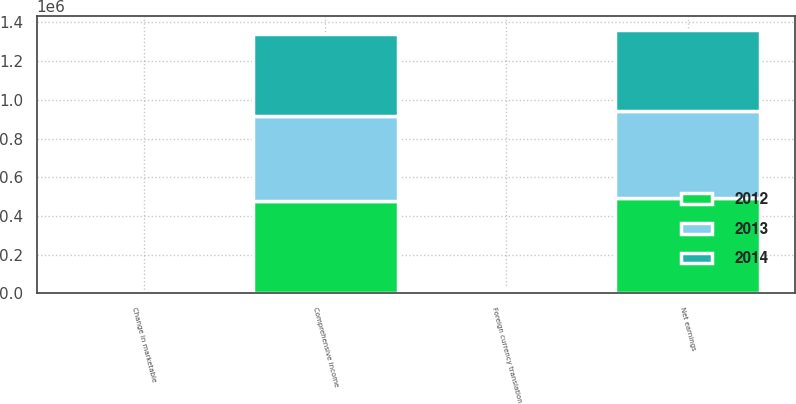<chart> <loc_0><loc_0><loc_500><loc_500><stacked_bar_chart><ecel><fcel>Net earnings<fcel>Foreign currency translation<fcel>Change in marketable<fcel>Comprehensive income<nl><fcel>2012<fcel>494150<fcel>18683<fcel>254<fcel>475213<nl><fcel>2013<fcel>448636<fcel>7354<fcel>98<fcel>441380<nl><fcel>2014<fcel>420536<fcel>3522<fcel>39<fcel>424097<nl></chart> 